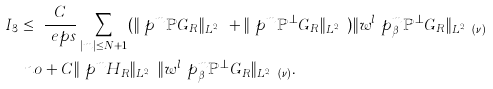<formula> <loc_0><loc_0><loc_500><loc_500>I _ { 3 } \leq \ & \frac { C } { \ e p s } \sum _ { | m | \leq N + 1 } ( \| \ p ^ { m } \mathbb { P } G _ { R } \| _ { L ^ { 2 } _ { x , v } } + \| \ p ^ { m } \mathbb { P } ^ { \perp } G _ { R } \| _ { L ^ { 2 } _ { x , v } } ) \| w ^ { l } \ p ^ { m } _ { \beta } \mathbb { P } ^ { \perp } G _ { R } \| _ { L ^ { 2 } _ { x , v } ( \nu ) } \\ \ n o & + C \| \ p ^ { m } H _ { R } \| _ { L ^ { 2 } _ { x , v } } \| w ^ { l } \ p ^ { m } _ { \beta } \mathbb { P } ^ { \perp } G _ { R } \| _ { L ^ { 2 } _ { x , v } ( \nu ) } .</formula> 